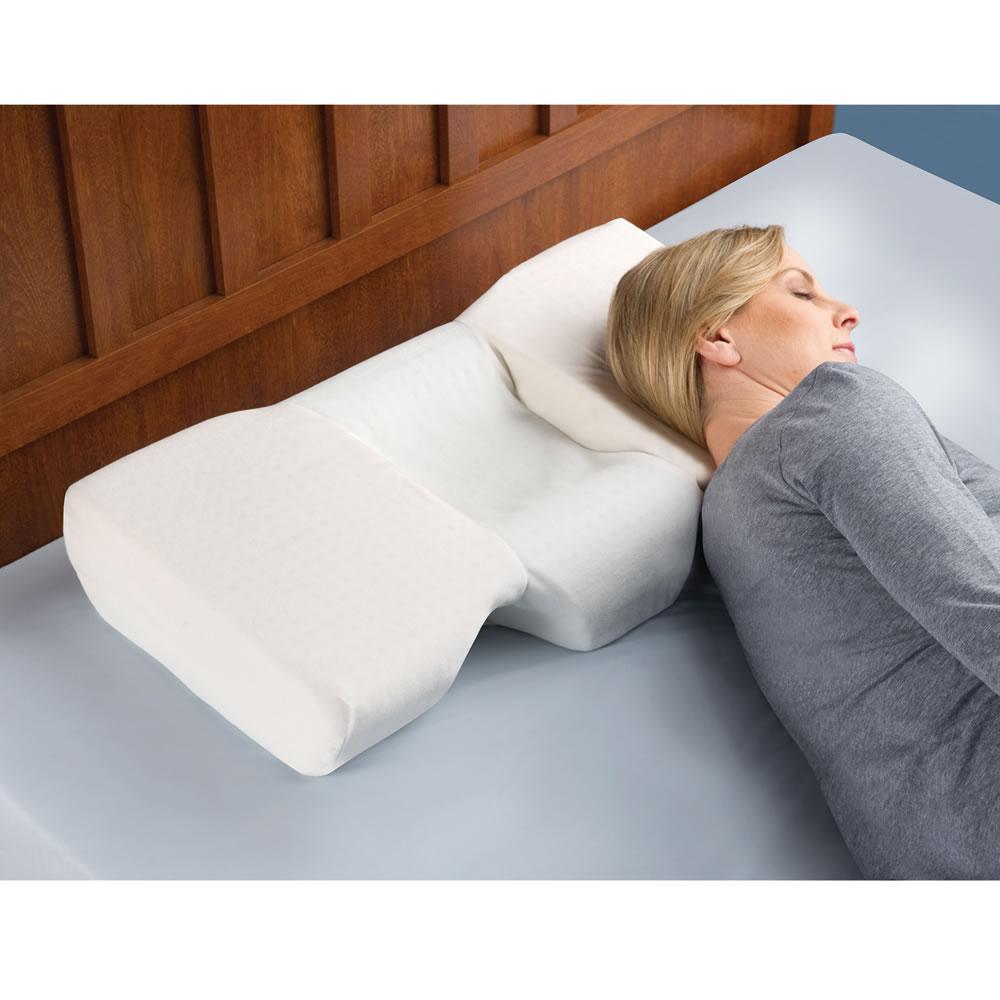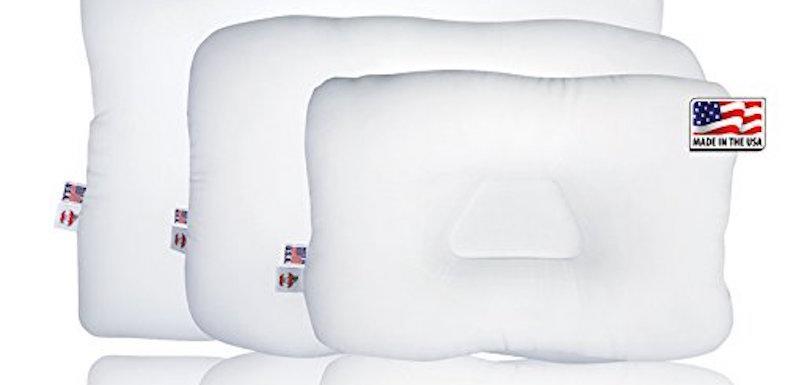The first image is the image on the left, the second image is the image on the right. Assess this claim about the two images: "In one image, a woman with dark hair rests her head on a pillow". Correct or not? Answer yes or no. No. The first image is the image on the left, the second image is the image on the right. Considering the images on both sides, is "A brunette woman is sleeping on a pillow" valid? Answer yes or no. No. 